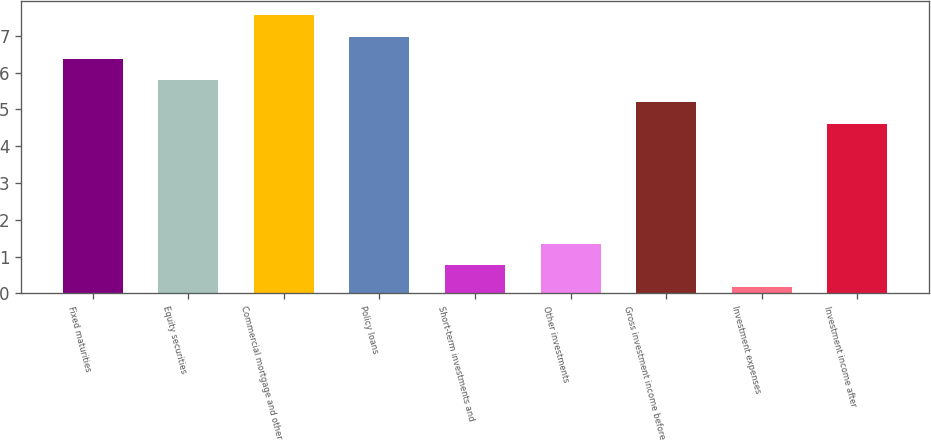<chart> <loc_0><loc_0><loc_500><loc_500><bar_chart><fcel>Fixed maturities<fcel>Equity securities<fcel>Commercial mortgage and other<fcel>Policy loans<fcel>Short-term investments and<fcel>Other investments<fcel>Gross investment income before<fcel>Investment expenses<fcel>Investment income after<nl><fcel>6.38<fcel>5.79<fcel>7.56<fcel>6.97<fcel>0.76<fcel>1.35<fcel>5.2<fcel>0.17<fcel>4.61<nl></chart> 